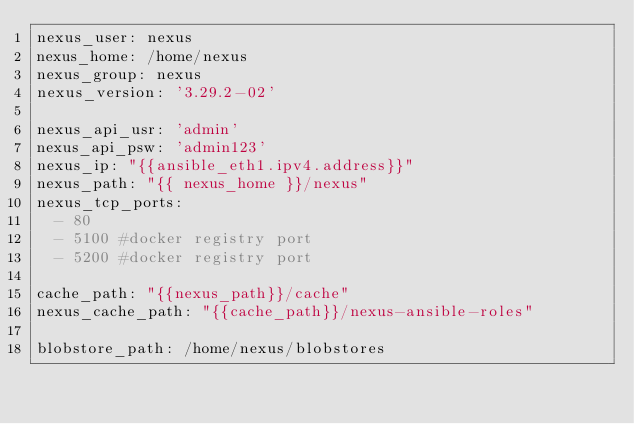<code> <loc_0><loc_0><loc_500><loc_500><_YAML_>nexus_user: nexus
nexus_home: /home/nexus
nexus_group: nexus
nexus_version: '3.29.2-02'

nexus_api_usr: 'admin'
nexus_api_psw: 'admin123'
nexus_ip: "{{ansible_eth1.ipv4.address}}"
nexus_path: "{{ nexus_home }}/nexus"
nexus_tcp_ports:
  - 80
  - 5100 #docker registry port
  - 5200 #docker registry port

cache_path: "{{nexus_path}}/cache"
nexus_cache_path: "{{cache_path}}/nexus-ansible-roles"

blobstore_path: /home/nexus/blobstores</code> 